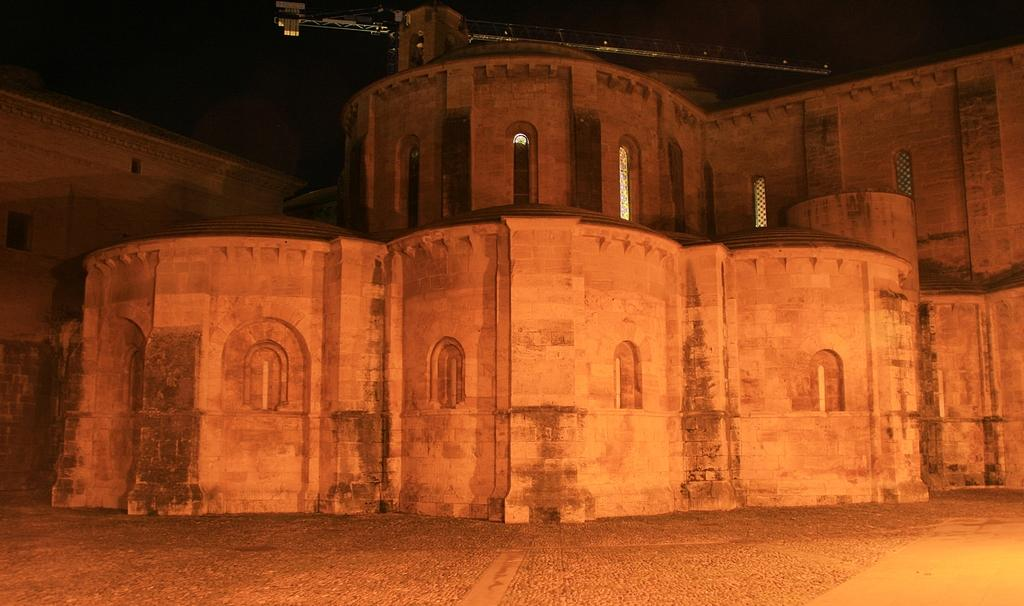What type of structures are present in the image? There are buildings in the image. What specific features can be observed on the buildings? The buildings have windows. Where are the buildings located? The buildings are on the ground. What is the color of the background in the image? The background of the image is dark in color. How many children are playing with pizzas in the image? There are no children or pizzas present in the image; it features buildings with windows on the ground, and the background is dark in color. 